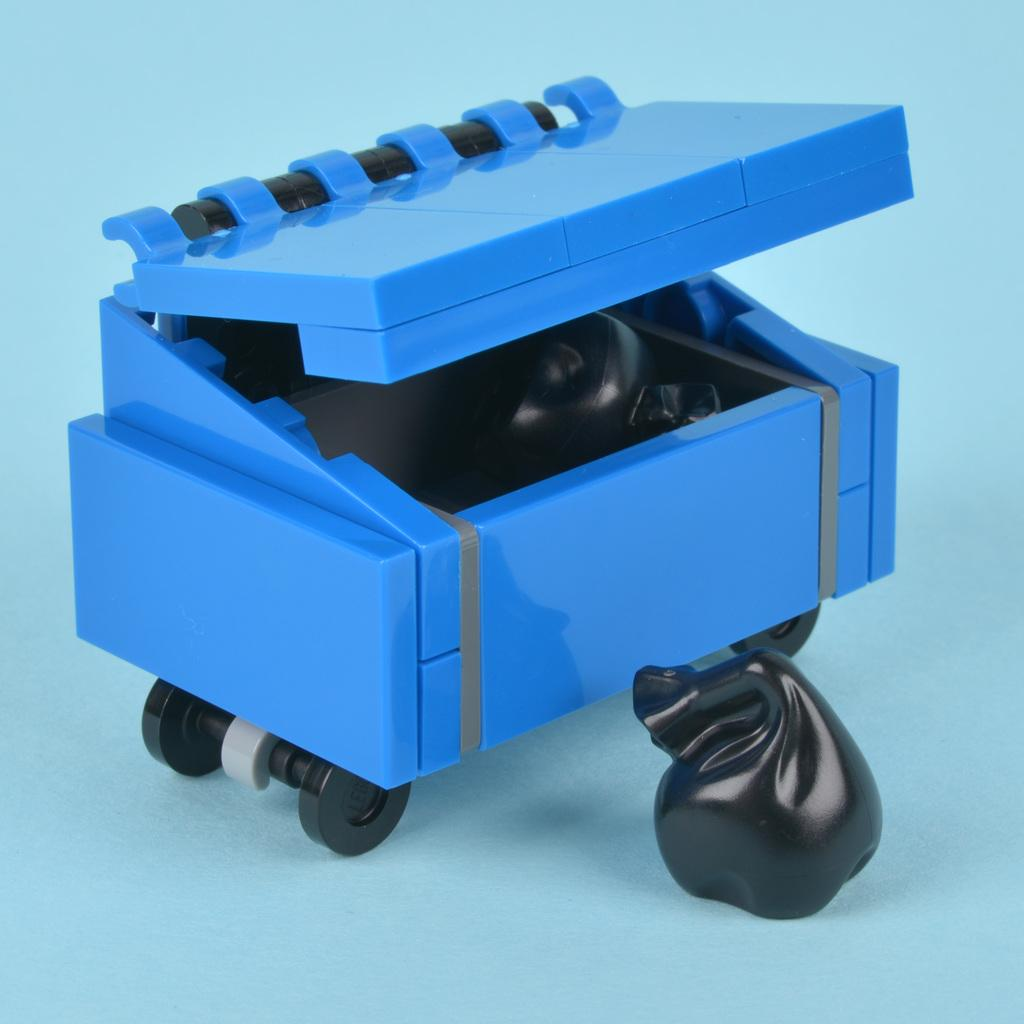What objects can be seen in the image? There are toys in the image. Where are the toys located? The toys are placed on a surface. What type of wood is used to make the toys in the image? There is no information about the material used to make the toys in the image, and therefore we cannot determine if wood is used. 